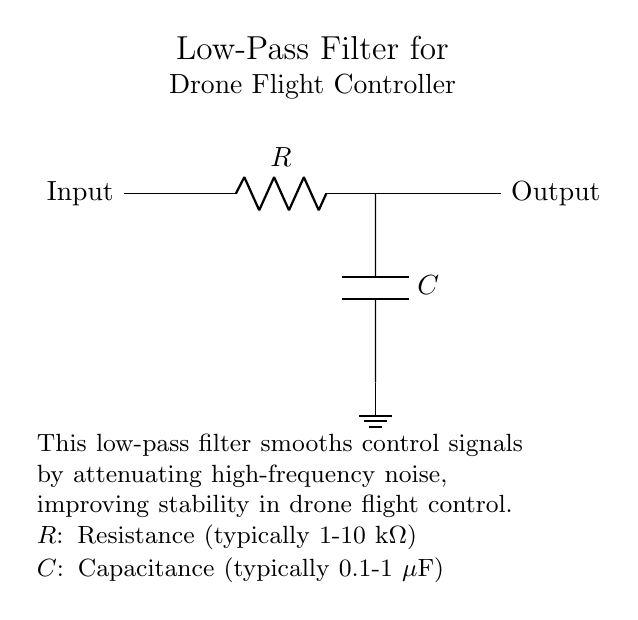What are the components in this filter circuit? The circuit consists of a resistor (R) and a capacitor (C). Identifying the symbols in the diagram, you can see one R and one C labeled.
Answer: Resistor and Capacitor What is the function of this low-pass filter in a drone? The purpose of this low-pass filter is to smooth control signals by attenuating high-frequency noise, enhancing stability in flight control. This is explained in the circuit's description as improving stability by reducing unwanted noise.
Answer: Smoothing control signals What is the typical range for resistance in this circuit? The schematic mentions that the resistance typically ranges from 1 to 10 kilo-ohms. This information is based on practical values used for R in low-pass filters.
Answer: 1 to 10 kilo-ohms What is the role of the capacitor in this low-pass filter? The capacitor in this filter acts to store charge and allows low-frequency signals to pass while blocking high-frequency signals. This role is fundamental to the operation of a low-pass filter.
Answer: Store charge and allow low frequencies What happens to high-frequency signals in this circuit? High-frequency signals are attenuated in a low-pass filter like this one, which means they are reduced or blocked, allowing only low-frequency signals to pass. This function is highlighted in the description of the circuit.
Answer: Attenuated What is the typical capacitance value for the capacitor in this circuit? The circuit outlines that the typical capacitance value ranges from 0.1 to 1 microfarad. This is based on standard component values used in this type of filter.
Answer: 0.1 to 1 microfarad What type of signals are ideal for processing with this low-pass filter? Ideal signals for this low-pass filter would be low-frequency control signals, as the circuit is designed to pass these signals while filtering out higher-frequency noise, thus ensuring stable control in drone operations.
Answer: Low-frequency control signals 